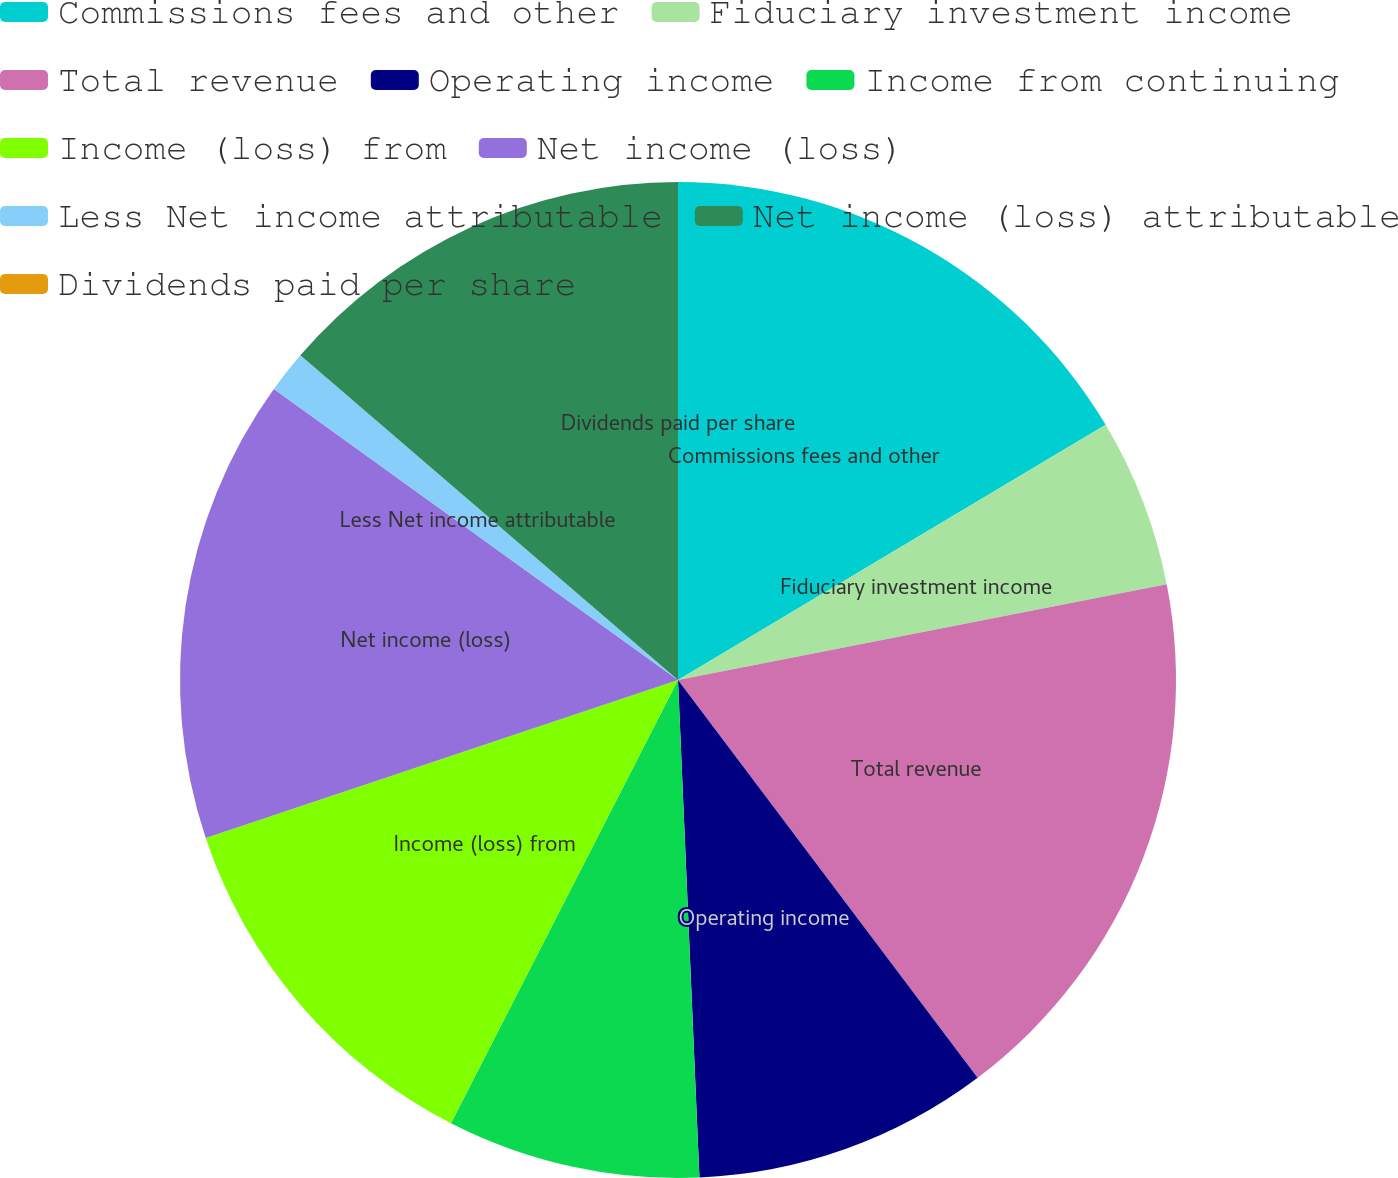Convert chart to OTSL. <chart><loc_0><loc_0><loc_500><loc_500><pie_chart><fcel>Commissions fees and other<fcel>Fiduciary investment income<fcel>Total revenue<fcel>Operating income<fcel>Income from continuing<fcel>Income (loss) from<fcel>Net income (loss)<fcel>Less Net income attributable<fcel>Net income (loss) attributable<fcel>Dividends paid per share<nl><fcel>16.44%<fcel>5.48%<fcel>17.81%<fcel>9.59%<fcel>8.22%<fcel>12.33%<fcel>15.07%<fcel>1.37%<fcel>13.7%<fcel>0.0%<nl></chart> 